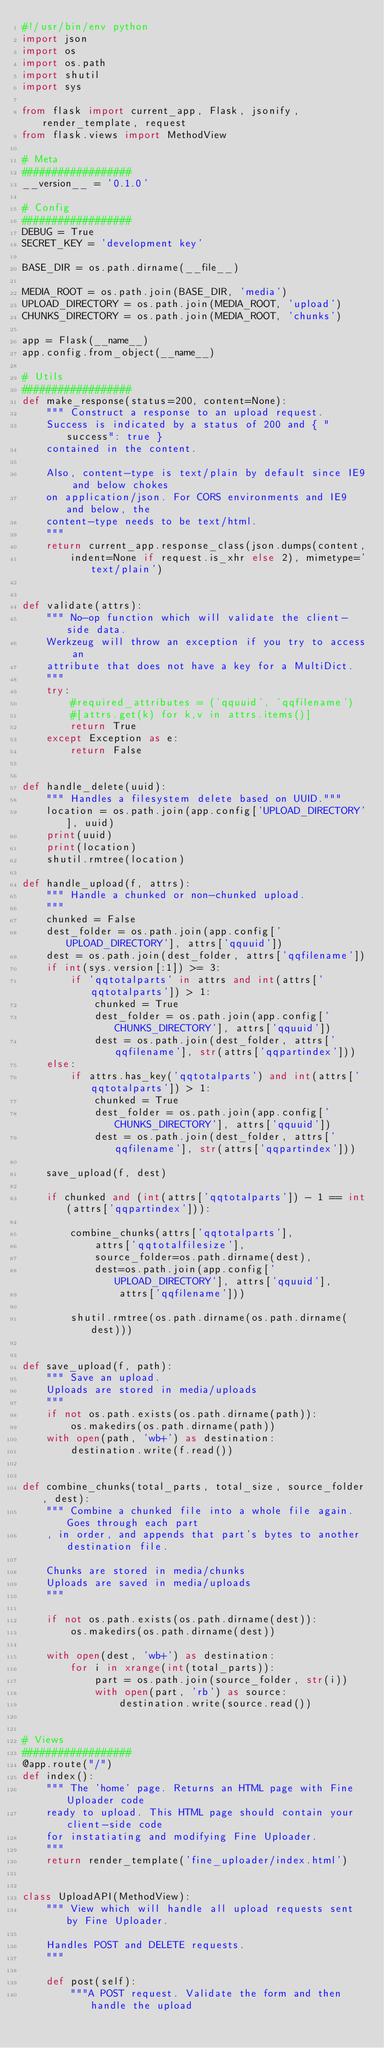Convert code to text. <code><loc_0><loc_0><loc_500><loc_500><_Python_>#!/usr/bin/env python
import json
import os
import os.path
import shutil
import sys

from flask import current_app, Flask, jsonify, render_template, request
from flask.views import MethodView

# Meta
##################
__version__ = '0.1.0'

# Config
##################
DEBUG = True
SECRET_KEY = 'development key'

BASE_DIR = os.path.dirname(__file__)

MEDIA_ROOT = os.path.join(BASE_DIR, 'media')
UPLOAD_DIRECTORY = os.path.join(MEDIA_ROOT, 'upload')
CHUNKS_DIRECTORY = os.path.join(MEDIA_ROOT, 'chunks')

app = Flask(__name__)
app.config.from_object(__name__)

# Utils
##################
def make_response(status=200, content=None):
    """ Construct a response to an upload request.
    Success is indicated by a status of 200 and { "success": true }
    contained in the content.

    Also, content-type is text/plain by default since IE9 and below chokes
    on application/json. For CORS environments and IE9 and below, the
    content-type needs to be text/html.
    """
    return current_app.response_class(json.dumps(content,
        indent=None if request.is_xhr else 2), mimetype='text/plain')


def validate(attrs):
    """ No-op function which will validate the client-side data.
    Werkzeug will throw an exception if you try to access an
    attribute that does not have a key for a MultiDict.
    """
    try:
        #required_attributes = ('qquuid', 'qqfilename')
        #[attrs.get(k) for k,v in attrs.items()]
        return True
    except Exception as e:
        return False


def handle_delete(uuid):
    """ Handles a filesystem delete based on UUID."""
    location = os.path.join(app.config['UPLOAD_DIRECTORY'], uuid)
    print(uuid)
    print(location)
    shutil.rmtree(location)

def handle_upload(f, attrs):
    """ Handle a chunked or non-chunked upload.
    """
    chunked = False
    dest_folder = os.path.join(app.config['UPLOAD_DIRECTORY'], attrs['qquuid'])
    dest = os.path.join(dest_folder, attrs['qqfilename'])
    if int(sys.version[:1]) >= 3:
        if 'qqtotalparts' in attrs and int(attrs['qqtotalparts']) > 1:
            chunked = True
            dest_folder = os.path.join(app.config['CHUNKS_DIRECTORY'], attrs['qquuid'])
            dest = os.path.join(dest_folder, attrs['qqfilename'], str(attrs['qqpartindex']))
    else:
        if attrs.has_key('qqtotalparts') and int(attrs['qqtotalparts']) > 1:
            chunked = True
            dest_folder = os.path.join(app.config['CHUNKS_DIRECTORY'], attrs['qquuid'])
            dest = os.path.join(dest_folder, attrs['qqfilename'], str(attrs['qqpartindex']))

    save_upload(f, dest)

    if chunked and (int(attrs['qqtotalparts']) - 1 == int(attrs['qqpartindex'])):

        combine_chunks(attrs['qqtotalparts'],
            attrs['qqtotalfilesize'],
            source_folder=os.path.dirname(dest),
            dest=os.path.join(app.config['UPLOAD_DIRECTORY'], attrs['qquuid'],
                attrs['qqfilename']))

        shutil.rmtree(os.path.dirname(os.path.dirname(dest)))


def save_upload(f, path):
    """ Save an upload.
    Uploads are stored in media/uploads
    """
    if not os.path.exists(os.path.dirname(path)):
        os.makedirs(os.path.dirname(path))
    with open(path, 'wb+') as destination:
        destination.write(f.read())


def combine_chunks(total_parts, total_size, source_folder, dest):
    """ Combine a chunked file into a whole file again. Goes through each part
    , in order, and appends that part's bytes to another destination file.

    Chunks are stored in media/chunks
    Uploads are saved in media/uploads
    """

    if not os.path.exists(os.path.dirname(dest)):
        os.makedirs(os.path.dirname(dest))

    with open(dest, 'wb+') as destination:
        for i in xrange(int(total_parts)):
            part = os.path.join(source_folder, str(i))
            with open(part, 'rb') as source:
                destination.write(source.read())


# Views
##################
@app.route("/")
def index():
    """ The 'home' page. Returns an HTML page with Fine Uploader code
    ready to upload. This HTML page should contain your client-side code
    for instatiating and modifying Fine Uploader.
    """
    return render_template('fine_uploader/index.html')


class UploadAPI(MethodView):
    """ View which will handle all upload requests sent by Fine Uploader.

    Handles POST and DELETE requests.
    """

    def post(self):
        """A POST request. Validate the form and then handle the upload</code> 